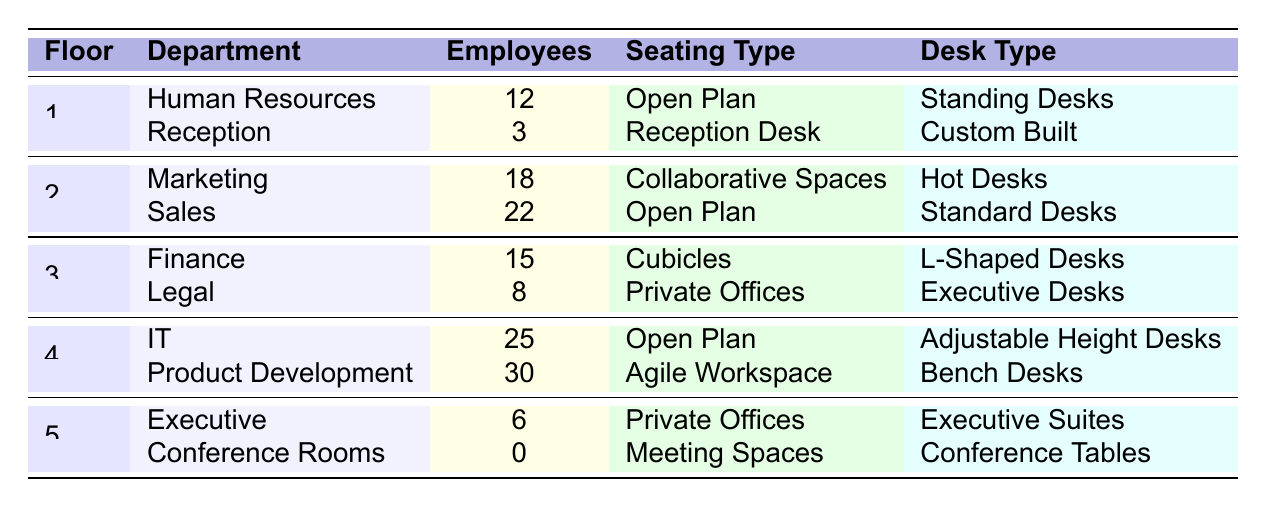What is the total number of employees on the 2nd floor? The table shows that on the 2nd floor, there are 18 employees in Marketing and 22 employees in Sales. Adding these together: 18 + 22 = 40.
Answer: 40 Which department has the most employees? The highest number of employees is in Product Development, which has 30 employees according to the table.
Answer: Product Development How many departments utilize Open Plan seating? The table indicates that there are three departments with Open Plan seating: Human Resources, Sales, and IT.
Answer: 3 Is there any department on the 5th floor with employees? The table shows that the Conference Rooms department has 0 employees, which means there are no employees on the 5th floor.
Answer: No What is the total number of employees across all floors? By adding all the employees from each department: 12 (HR) + 3 (Reception) + 18 (Marketing) + 22 (Sales) + 15 (Finance) + 8 (Legal) + 25 (IT) + 30 (Product Development) + 6 (Executive) + 0 (Conference) = 139.
Answer: 139 How many more employees are in the IT department compared to the Legal department? The IT department has 25 employees and the Legal department has 8 employees. The difference is 25 - 8 = 17.
Answer: 17 What is the average number of employees per floor? There are 5 floors with a total of 139 employees. The average is calculated by dividing total employees by the number of floors: 139 / 5 = 27.8.
Answer: 27.8 Are there any private offices on the first floor? The table shows that the first floor has HR and Reception departments, neither of which has Private Offices; hence, there are none on the first floor.
Answer: No Which floor has the highest number of total employees? Floor 4 has 55 employees (25 in IT and 30 in Product Development), which is the highest compared to other floors.
Answer: 4th floor What is the seating type for the department with the least number of employees? The department with the fewest employees is the Reception department with 3, which has a seating type of Reception Desk.
Answer: Reception Desk 